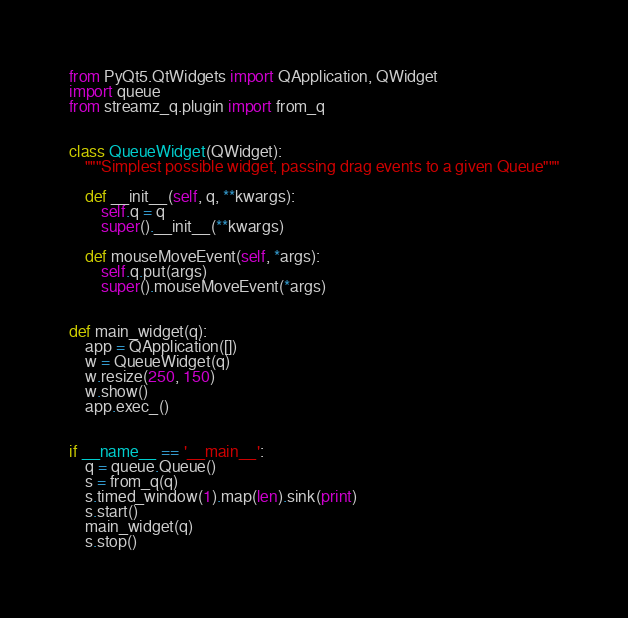Convert code to text. <code><loc_0><loc_0><loc_500><loc_500><_Python_>from PyQt5.QtWidgets import QApplication, QWidget
import queue
from streamz_q.plugin import from_q


class QueueWidget(QWidget):
    """Simplest possible widget, passing drag events to a given Queue"""

    def __init__(self, q, **kwargs):
        self.q = q
        super().__init__(**kwargs)

    def mouseMoveEvent(self, *args):
        self.q.put(args)
        super().mouseMoveEvent(*args)


def main_widget(q):
    app = QApplication([])
    w = QueueWidget(q)
    w.resize(250, 150)
    w.show()
    app.exec_()


if __name__ == '__main__':
    q = queue.Queue()
    s = from_q(q)
    s.timed_window(1).map(len).sink(print)
    s.start()
    main_widget(q)
    s.stop()
</code> 